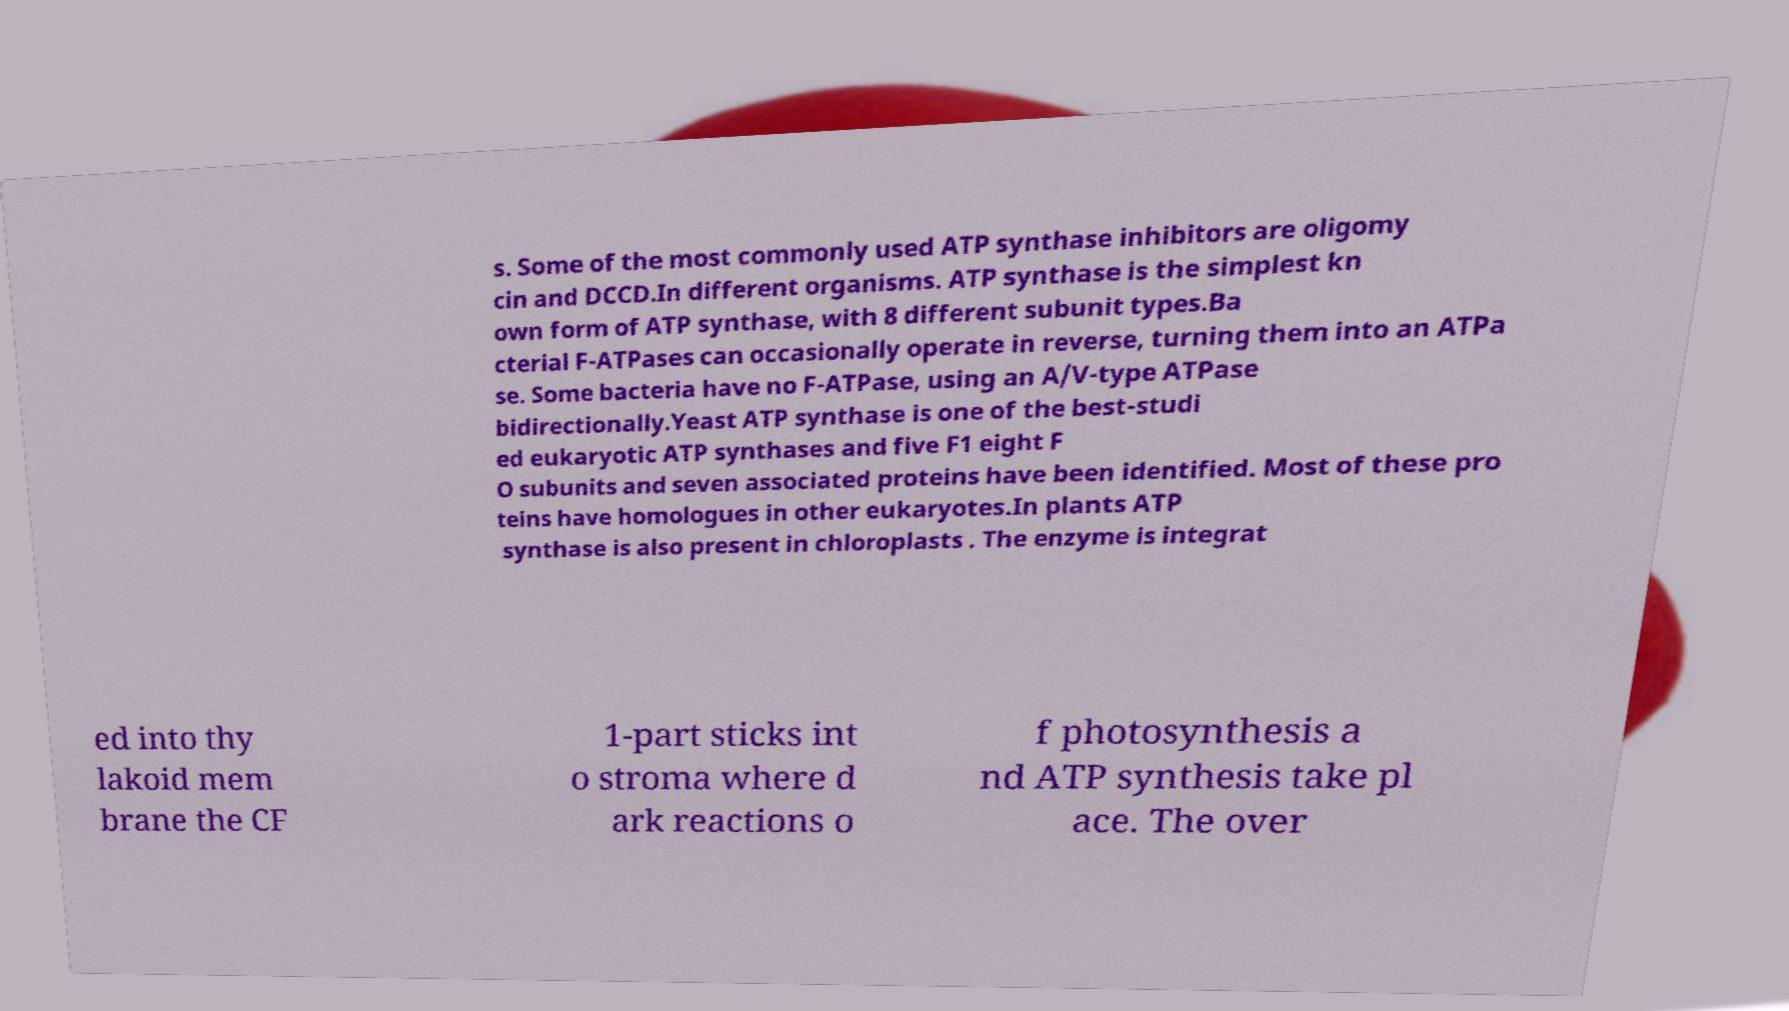Can you accurately transcribe the text from the provided image for me? s. Some of the most commonly used ATP synthase inhibitors are oligomy cin and DCCD.In different organisms. ATP synthase is the simplest kn own form of ATP synthase, with 8 different subunit types.Ba cterial F-ATPases can occasionally operate in reverse, turning them into an ATPa se. Some bacteria have no F-ATPase, using an A/V-type ATPase bidirectionally.Yeast ATP synthase is one of the best-studi ed eukaryotic ATP synthases and five F1 eight F O subunits and seven associated proteins have been identified. Most of these pro teins have homologues in other eukaryotes.In plants ATP synthase is also present in chloroplasts . The enzyme is integrat ed into thy lakoid mem brane the CF 1-part sticks int o stroma where d ark reactions o f photosynthesis a nd ATP synthesis take pl ace. The over 